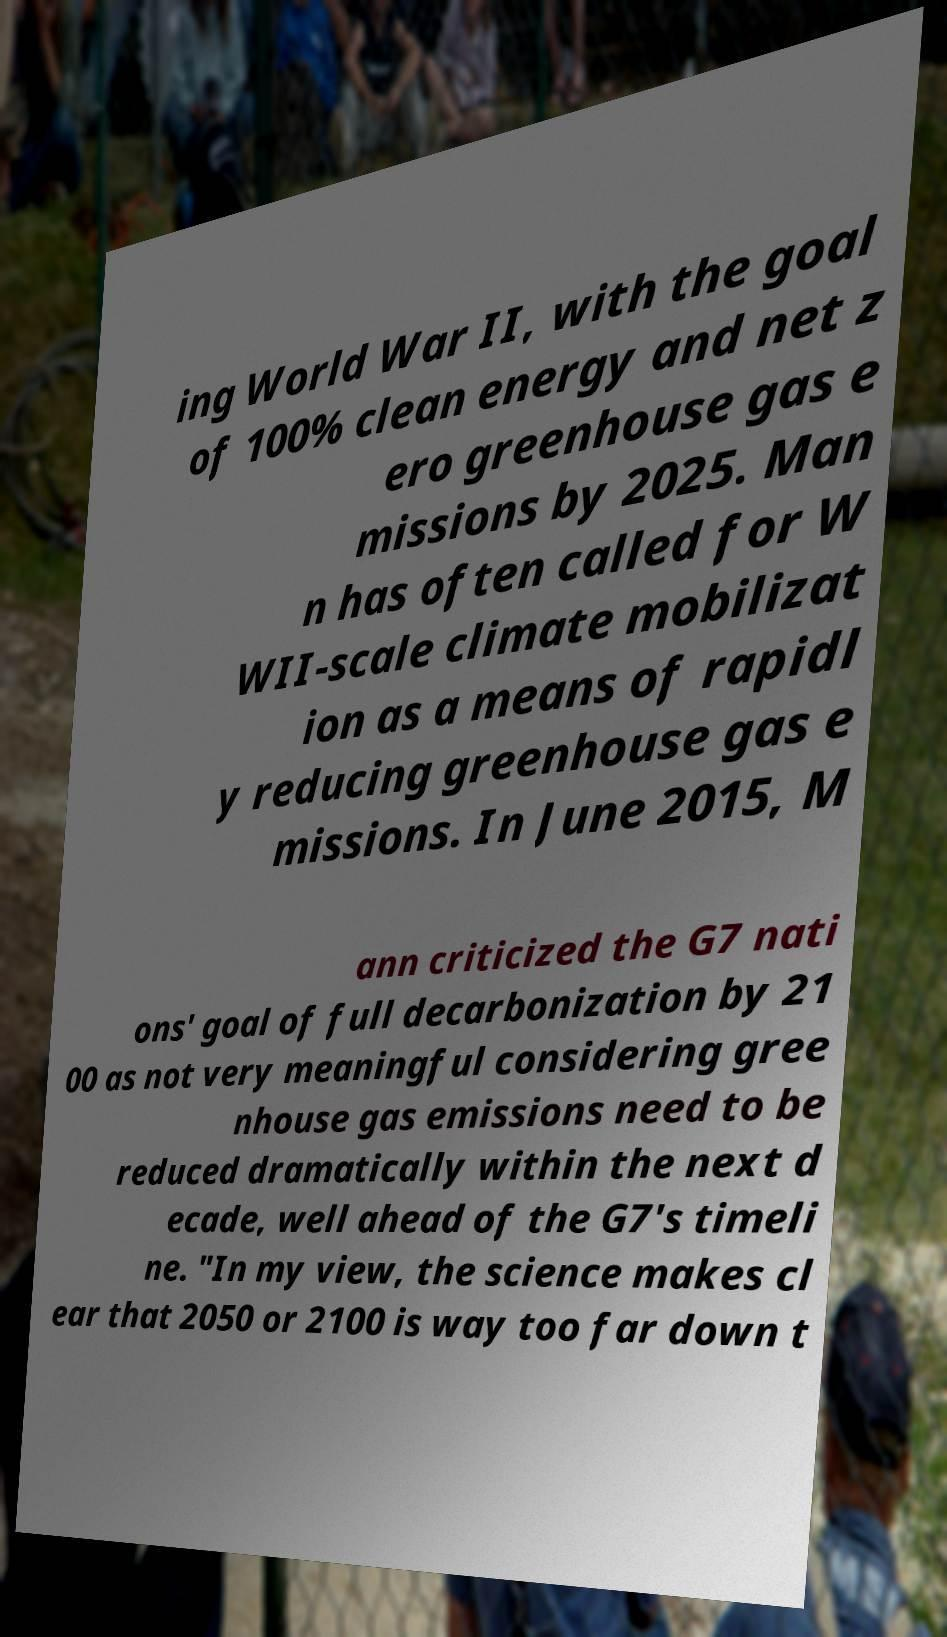Please read and relay the text visible in this image. What does it say? ing World War II, with the goal of 100% clean energy and net z ero greenhouse gas e missions by 2025. Man n has often called for W WII-scale climate mobilizat ion as a means of rapidl y reducing greenhouse gas e missions. In June 2015, M ann criticized the G7 nati ons' goal of full decarbonization by 21 00 as not very meaningful considering gree nhouse gas emissions need to be reduced dramatically within the next d ecade, well ahead of the G7's timeli ne. "In my view, the science makes cl ear that 2050 or 2100 is way too far down t 